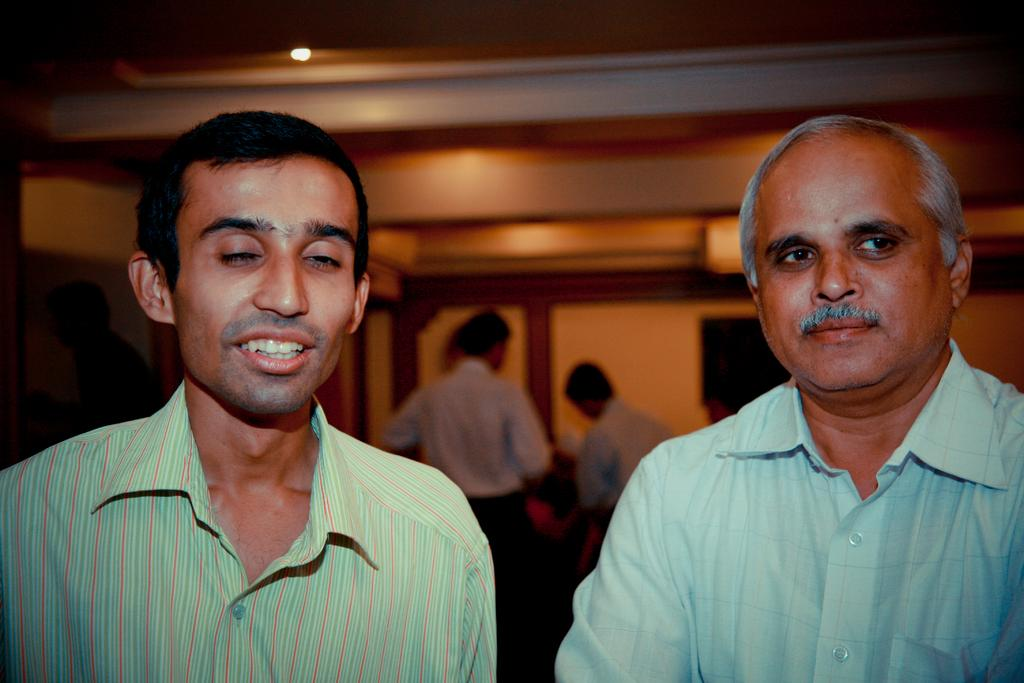How many people are present in the image? There are two persons in the image. What can be seen in the background of the image? There is a wall, a light, a television, and a group of people in the background of the image. Can you describe the lighting in the image? There is a light visible in the background of the image. What might the group of people be doing in the background? It is not clear what the group of people is doing in the background, but they are present in the image. What type of chain is being used to hold the attention of the persons in the image? There is no chain present in the image, and the persons' attention is not being held by any chain. 